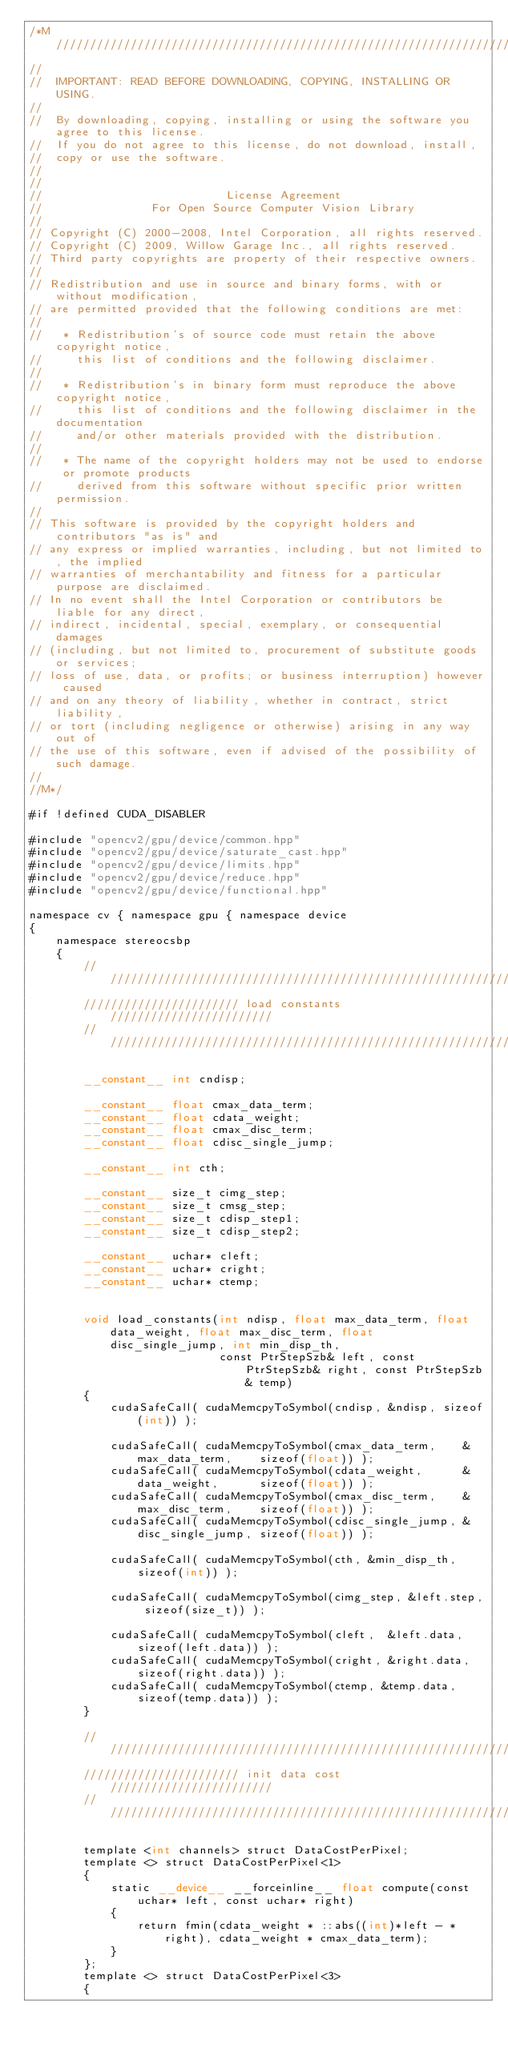Convert code to text. <code><loc_0><loc_0><loc_500><loc_500><_Cuda_>/*M///////////////////////////////////////////////////////////////////////////////////////
//
//  IMPORTANT: READ BEFORE DOWNLOADING, COPYING, INSTALLING OR USING.
//
//  By downloading, copying, installing or using the software you agree to this license.
//  If you do not agree to this license, do not download, install,
//  copy or use the software.
//
//
//                           License Agreement
//                For Open Source Computer Vision Library
//
// Copyright (C) 2000-2008, Intel Corporation, all rights reserved.
// Copyright (C) 2009, Willow Garage Inc., all rights reserved.
// Third party copyrights are property of their respective owners.
//
// Redistribution and use in source and binary forms, with or without modification,
// are permitted provided that the following conditions are met:
//
//   * Redistribution's of source code must retain the above copyright notice,
//     this list of conditions and the following disclaimer.
//
//   * Redistribution's in binary form must reproduce the above copyright notice,
//     this list of conditions and the following disclaimer in the documentation
//     and/or other materials provided with the distribution.
//
//   * The name of the copyright holders may not be used to endorse or promote products
//     derived from this software without specific prior written permission.
//
// This software is provided by the copyright holders and contributors "as is" and
// any express or implied warranties, including, but not limited to, the implied
// warranties of merchantability and fitness for a particular purpose are disclaimed.
// In no event shall the Intel Corporation or contributors be liable for any direct,
// indirect, incidental, special, exemplary, or consequential damages
// (including, but not limited to, procurement of substitute goods or services;
// loss of use, data, or profits; or business interruption) however caused
// and on any theory of liability, whether in contract, strict liability,
// or tort (including negligence or otherwise) arising in any way out of
// the use of this software, even if advised of the possibility of such damage.
//
//M*/

#if !defined CUDA_DISABLER

#include "opencv2/gpu/device/common.hpp"
#include "opencv2/gpu/device/saturate_cast.hpp"
#include "opencv2/gpu/device/limits.hpp"
#include "opencv2/gpu/device/reduce.hpp"
#include "opencv2/gpu/device/functional.hpp"

namespace cv { namespace gpu { namespace device
{
    namespace stereocsbp
    {
        ///////////////////////////////////////////////////////////////
        /////////////////////// load constants ////////////////////////
        ///////////////////////////////////////////////////////////////

        __constant__ int cndisp;

        __constant__ float cmax_data_term;
        __constant__ float cdata_weight;
        __constant__ float cmax_disc_term;
        __constant__ float cdisc_single_jump;

        __constant__ int cth;

        __constant__ size_t cimg_step;
        __constant__ size_t cmsg_step;
        __constant__ size_t cdisp_step1;
        __constant__ size_t cdisp_step2;

        __constant__ uchar* cleft;
        __constant__ uchar* cright;
        __constant__ uchar* ctemp;


        void load_constants(int ndisp, float max_data_term, float data_weight, float max_disc_term, float disc_single_jump, int min_disp_th,
                            const PtrStepSzb& left, const PtrStepSzb& right, const PtrStepSzb& temp)
        {
            cudaSafeCall( cudaMemcpyToSymbol(cndisp, &ndisp, sizeof(int)) );

            cudaSafeCall( cudaMemcpyToSymbol(cmax_data_term,    &max_data_term,    sizeof(float)) );
            cudaSafeCall( cudaMemcpyToSymbol(cdata_weight,      &data_weight,      sizeof(float)) );
            cudaSafeCall( cudaMemcpyToSymbol(cmax_disc_term,    &max_disc_term,    sizeof(float)) );
            cudaSafeCall( cudaMemcpyToSymbol(cdisc_single_jump, &disc_single_jump, sizeof(float)) );

            cudaSafeCall( cudaMemcpyToSymbol(cth, &min_disp_th, sizeof(int)) );

            cudaSafeCall( cudaMemcpyToSymbol(cimg_step, &left.step, sizeof(size_t)) );

            cudaSafeCall( cudaMemcpyToSymbol(cleft,  &left.data,  sizeof(left.data)) );
            cudaSafeCall( cudaMemcpyToSymbol(cright, &right.data, sizeof(right.data)) );
            cudaSafeCall( cudaMemcpyToSymbol(ctemp, &temp.data, sizeof(temp.data)) );
        }

        ///////////////////////////////////////////////////////////////
        /////////////////////// init data cost ////////////////////////
        ///////////////////////////////////////////////////////////////

        template <int channels> struct DataCostPerPixel;
        template <> struct DataCostPerPixel<1>
        {
            static __device__ __forceinline__ float compute(const uchar* left, const uchar* right)
            {
                return fmin(cdata_weight * ::abs((int)*left - *right), cdata_weight * cmax_data_term);
            }
        };
        template <> struct DataCostPerPixel<3>
        {</code> 